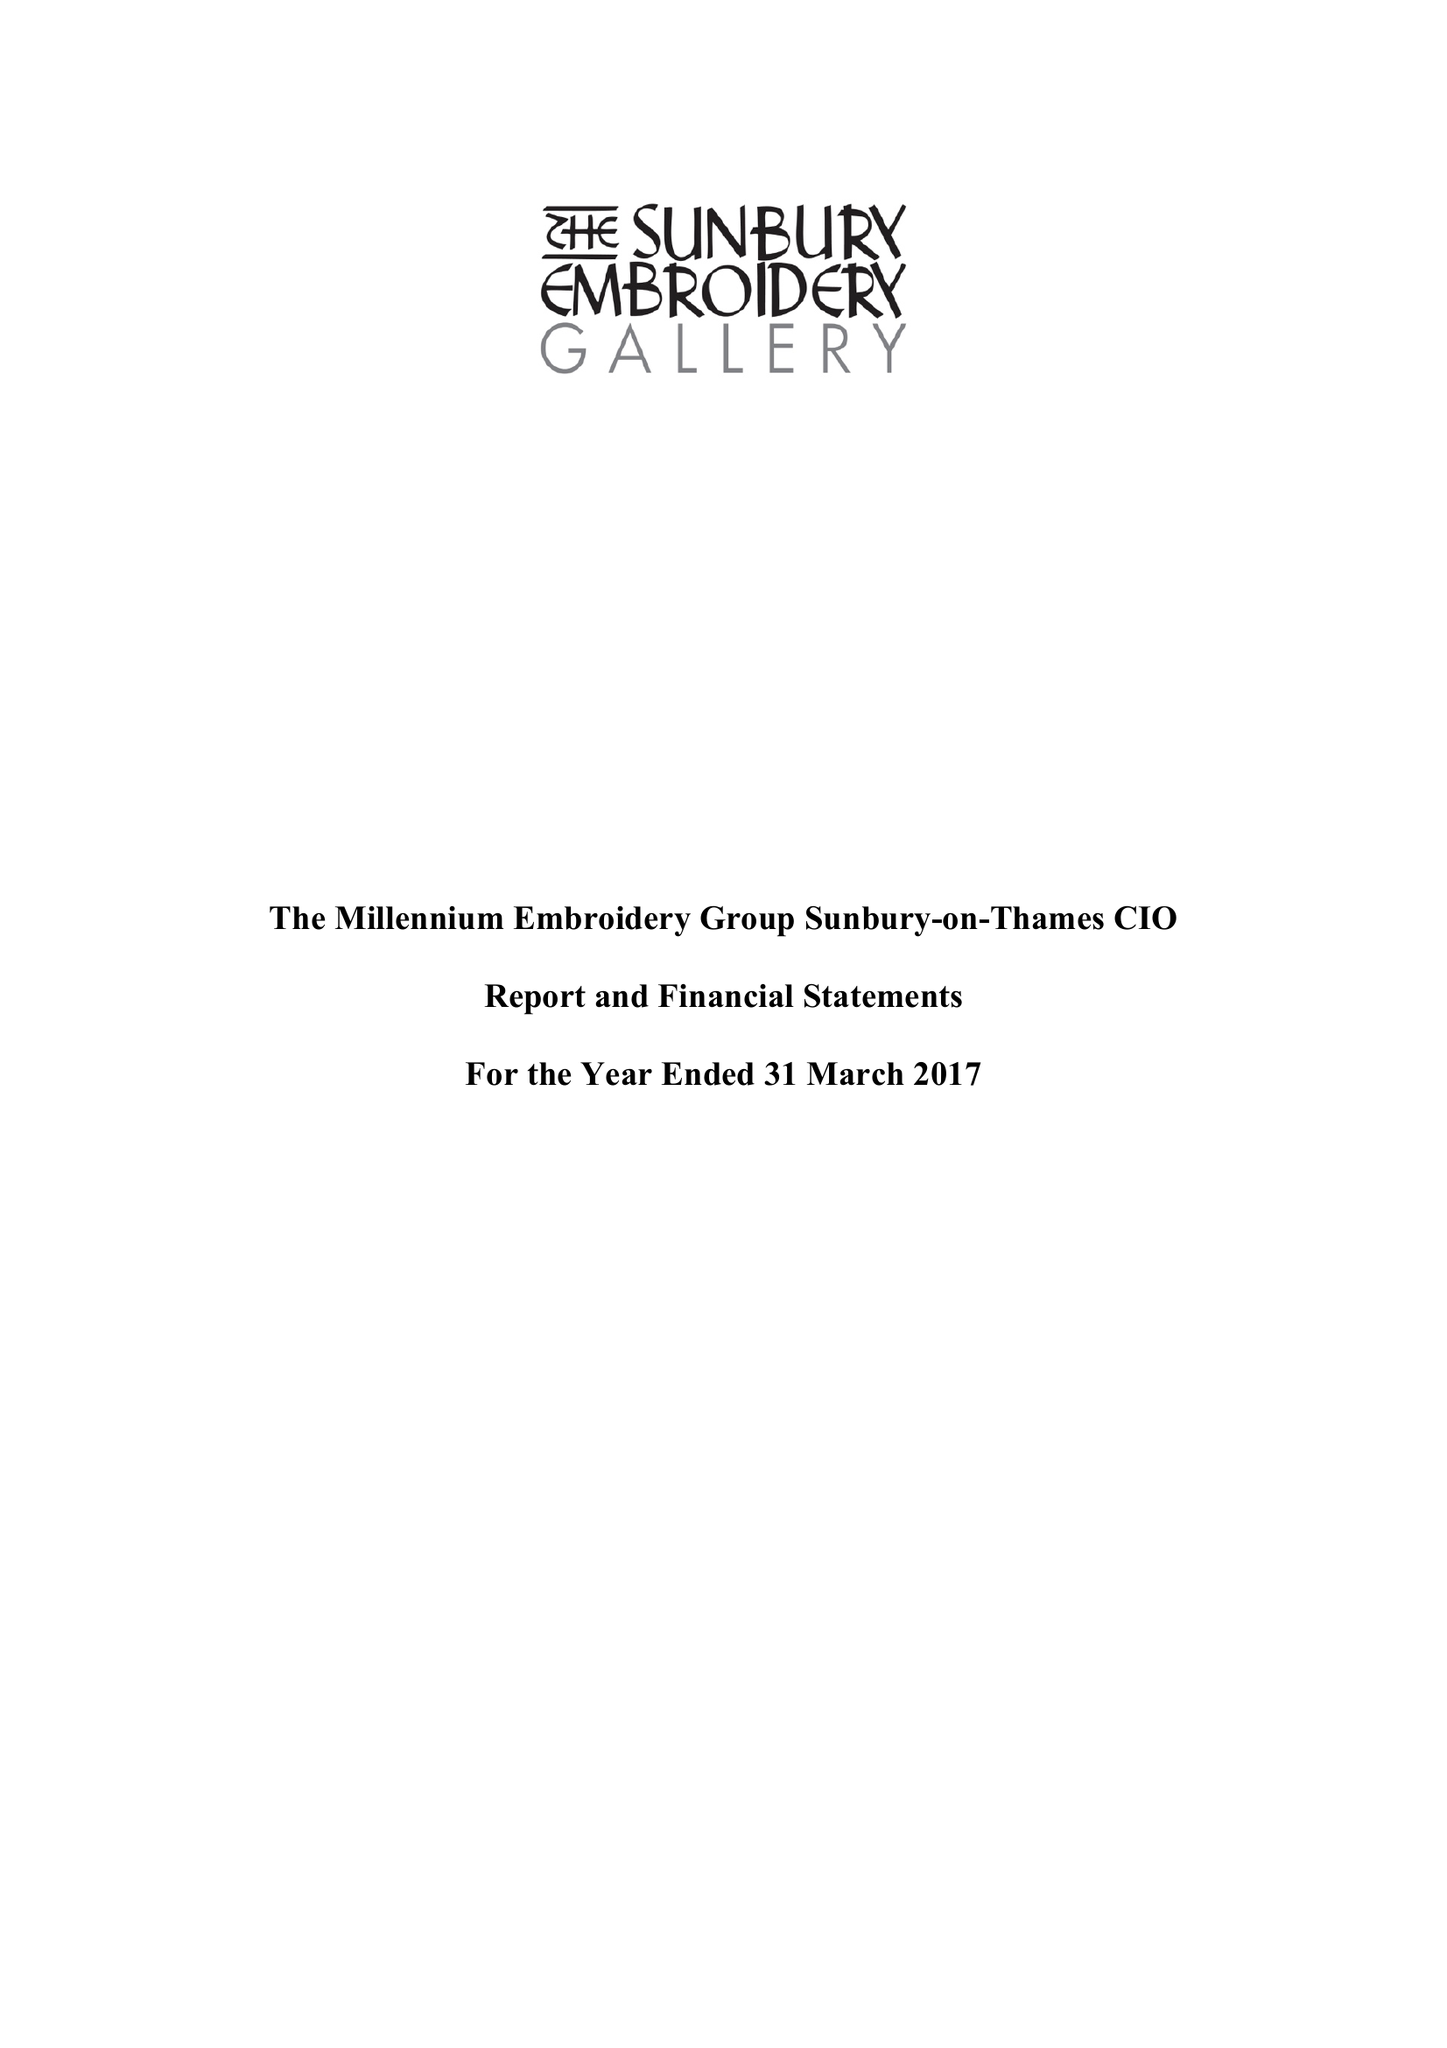What is the value for the address__post_town?
Answer the question using a single word or phrase. SUNBURY-ON-THAMES 